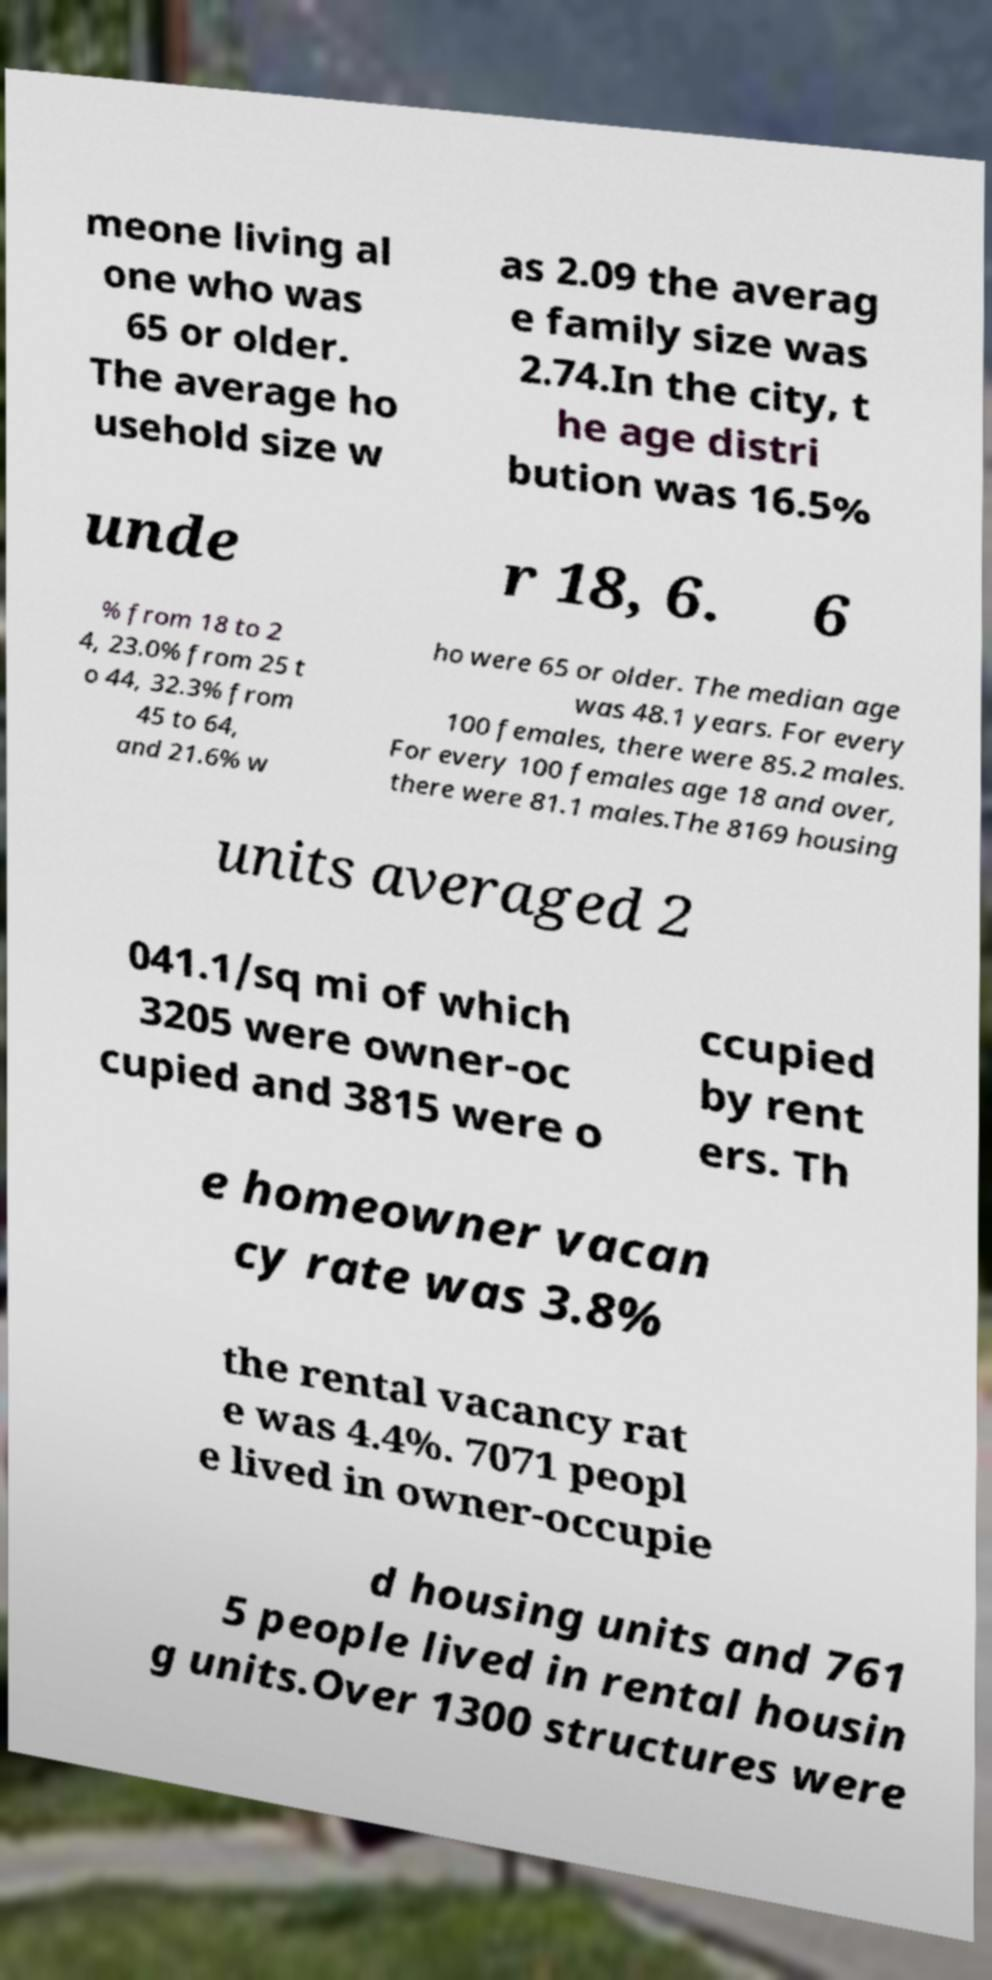For documentation purposes, I need the text within this image transcribed. Could you provide that? meone living al one who was 65 or older. The average ho usehold size w as 2.09 the averag e family size was 2.74.In the city, t he age distri bution was 16.5% unde r 18, 6. 6 % from 18 to 2 4, 23.0% from 25 t o 44, 32.3% from 45 to 64, and 21.6% w ho were 65 or older. The median age was 48.1 years. For every 100 females, there were 85.2 males. For every 100 females age 18 and over, there were 81.1 males.The 8169 housing units averaged 2 041.1/sq mi of which 3205 were owner-oc cupied and 3815 were o ccupied by rent ers. Th e homeowner vacan cy rate was 3.8% the rental vacancy rat e was 4.4%. 7071 peopl e lived in owner-occupie d housing units and 761 5 people lived in rental housin g units.Over 1300 structures were 